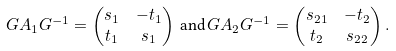Convert formula to latex. <formula><loc_0><loc_0><loc_500><loc_500>G A _ { 1 } G ^ { - 1 } & = \begin{pmatrix} s _ { 1 } & - t _ { 1 } \\ t _ { 1 } & s _ { 1 } \end{pmatrix} \, \text {and} \, G A _ { 2 } G ^ { - 1 } = \begin{pmatrix} s _ { 2 1 } & - t _ { 2 } \\ t _ { 2 } & s _ { 2 2 } \end{pmatrix} .</formula> 